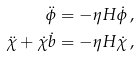<formula> <loc_0><loc_0><loc_500><loc_500>\ddot { \phi } & = - \eta H \dot { \phi } \, , \\ \ddot { \chi } + \dot { \chi } \dot { b } & = - \eta H \dot { \chi } \, ,</formula> 